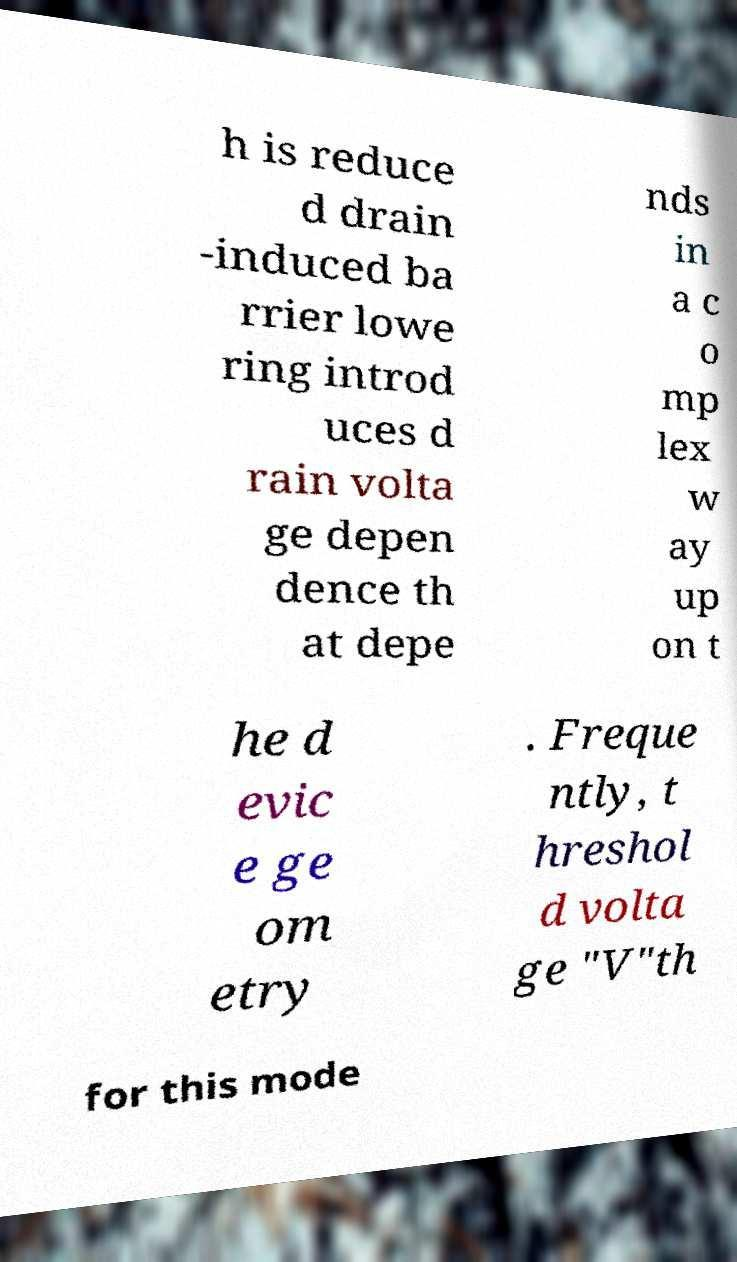Can you read and provide the text displayed in the image?This photo seems to have some interesting text. Can you extract and type it out for me? h is reduce d drain -induced ba rrier lowe ring introd uces d rain volta ge depen dence th at depe nds in a c o mp lex w ay up on t he d evic e ge om etry . Freque ntly, t hreshol d volta ge "V"th for this mode 